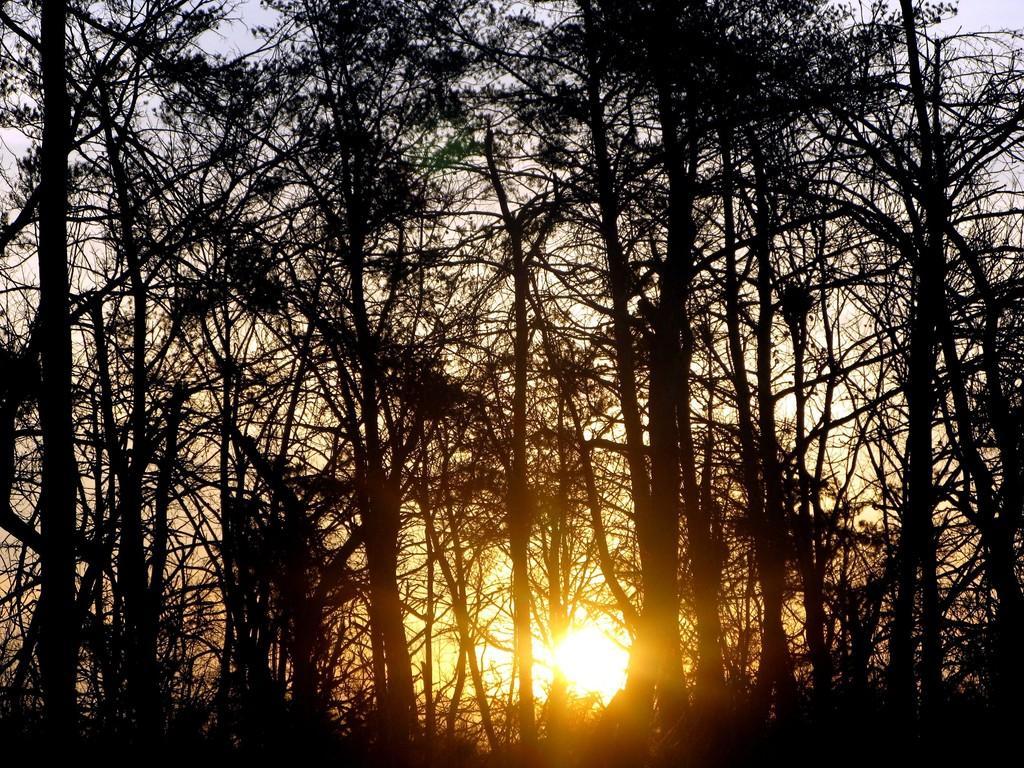Could you give a brief overview of what you see in this image? In this image I can see many trees. In the back there is a sun and the sky. 